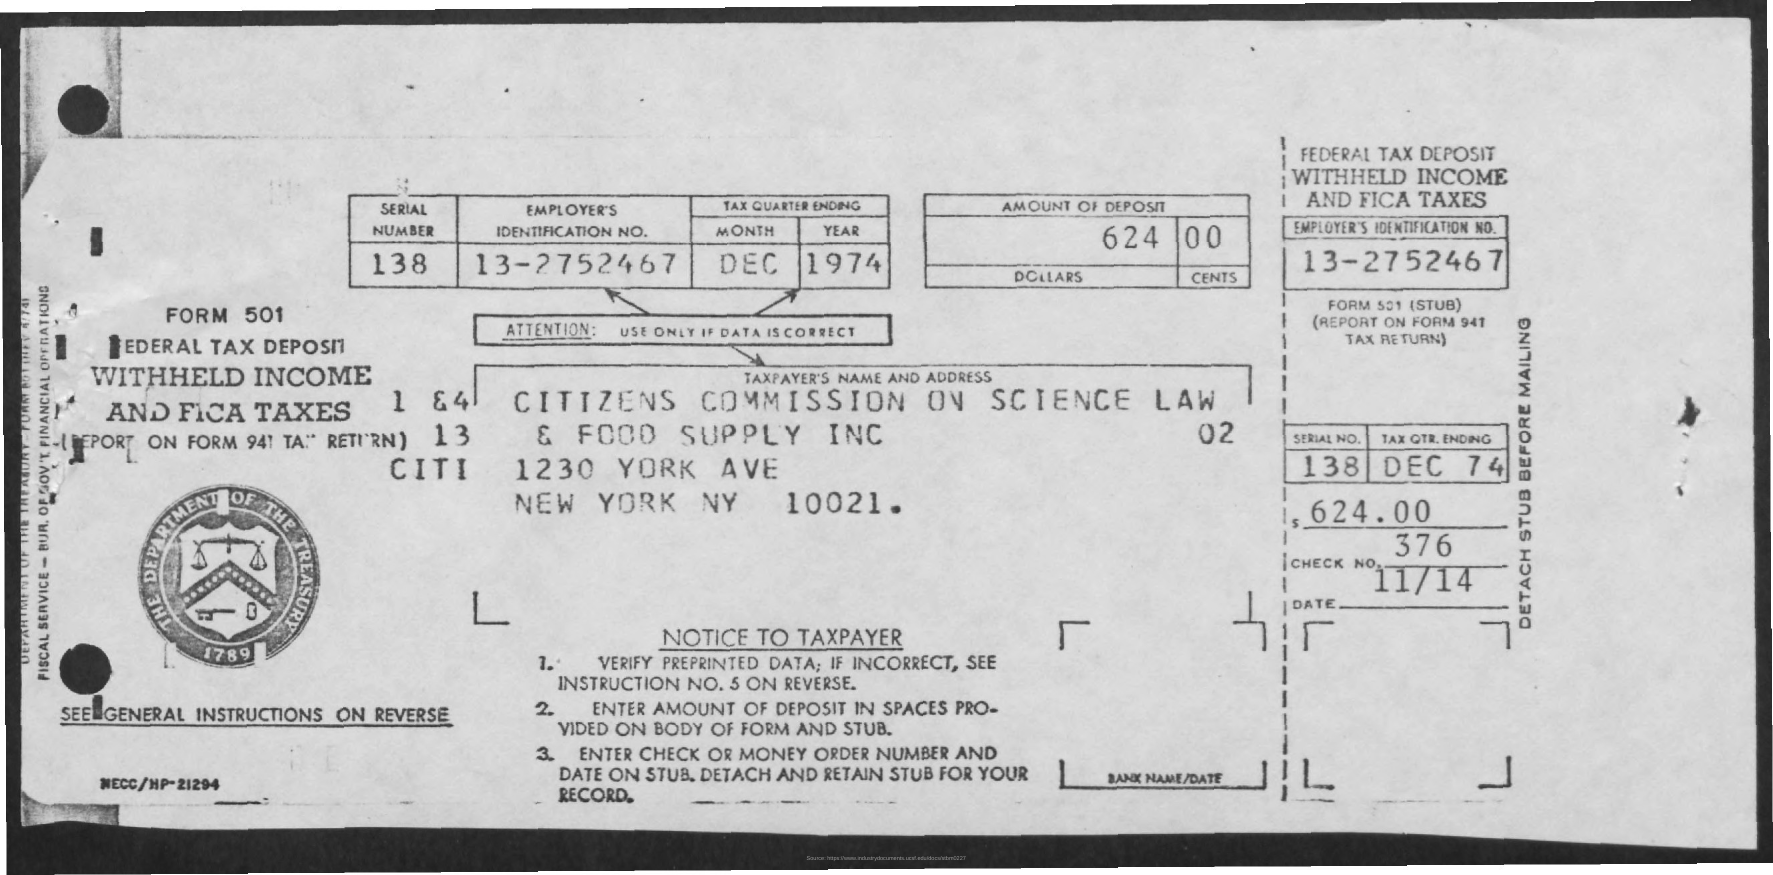Who would have been issuing this document? The issuer of this document would typically be the financial department or payroll department of an employer, such as the Citizens Commission on Science, Law, and Food Supply Inc., whose name and address are indicated on the form. They would complete this document to report tax withholdings and submit it, along with the payment, to the IRS. 